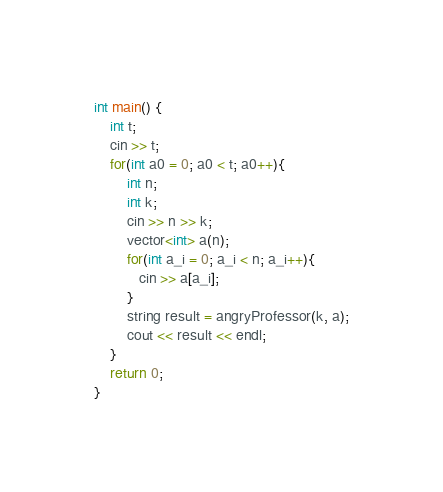<code> <loc_0><loc_0><loc_500><loc_500><_C++_>int main() {
    int t;
    cin >> t;
    for(int a0 = 0; a0 < t; a0++){
        int n;
        int k;
        cin >> n >> k;
        vector<int> a(n);
        for(int a_i = 0; a_i < n; a_i++){
           cin >> a[a_i];
        }
        string result = angryProfessor(k, a);
        cout << result << endl;
    }
    return 0;
}
</code> 